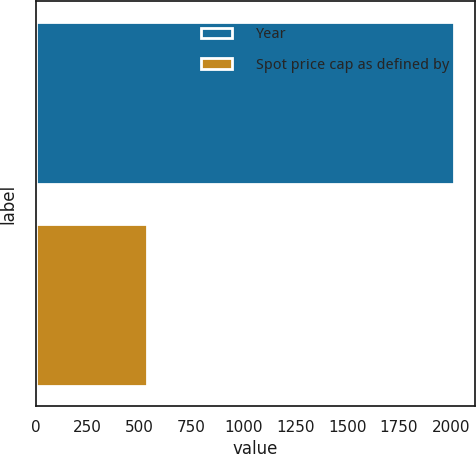Convert chart to OTSL. <chart><loc_0><loc_0><loc_500><loc_500><bar_chart><fcel>Year<fcel>Spot price cap as defined by<nl><fcel>2017<fcel>534<nl></chart> 